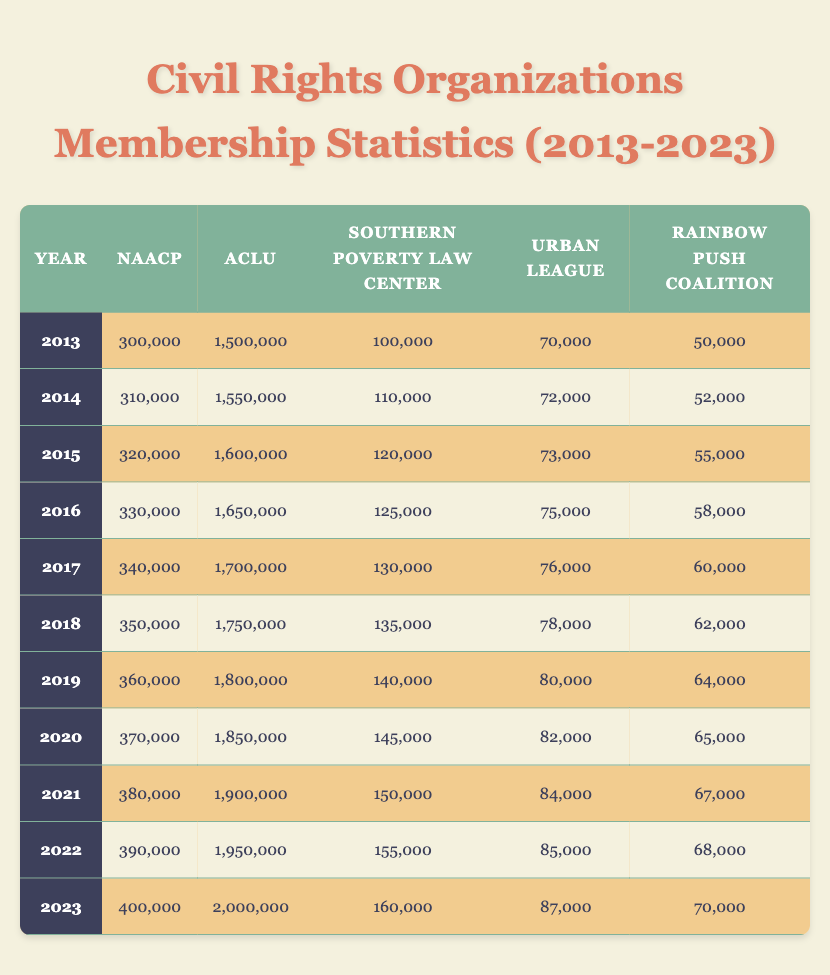What was the NAACP membership in 2013? The table shows that the NAACP membership in the year 2013 was listed as 300,000.
Answer: 300,000 Which organization had the highest membership in 2023? In 2023, the ACLU membership, which is 2,000,000, is higher than the memberships of other organizations listed for that year.
Answer: ACLU What is the difference in membership for the Southern Poverty Law Center between 2015 and 2020? For 2015, the Southern Poverty Law Center had a membership of 120,000 and in 2020 it was 145,000. The difference is 145,000 - 120,000 = 25,000.
Answer: 25,000 In which year did the Rainbow Push Coalition reach a membership of 60,000? By reviewing the table, it indicates that the Rainbow Push Coalition's membership reached 60,000 in 2017.
Answer: 2017 What was the average membership of the Urban League over the decade? To find the average, sum the Urban League memberships from 2013 to 2023, which are 70,000, 72,000, 73,000, 75,000, 76,000, 78,000, 80,000, 82,000, 84,000, 85,000, and 87,000, totaling  70,000 + 72,000 + 73,000 + 75,000 + 76,000 + 78,000 + 80,000 + 82,000 + 84,000 + 85,000 + 87,000 =  65,727. Dividing by 11 gives an average of approximately 81,000.
Answer: 81,000 Did the NAACP membership increase every year from 2013 to 2023? By examining the table, it's clear that the NAACP membership increased each year, starting from 300,000 in 2013 to 400,000 in 2023 without any decreases.
Answer: Yes What was the total membership for the ACLU over the years from 2013 to 2023? The total membership is found by adding the yearly memberships: 1,500,000 + 1,550,000 + 1,600,000 + 1,650,000 + 1,700,000 + 1,750,000 + 1,800,000 + 1,850,000 + 1,900,000 + 1,950,000 + 2,000,000 = 19,800,000.
Answer: 19,800,000 Which organization saw the smallest growth over the decade? By looking at the growth of each organization, the Rainbow Push Coalition’s membership increased from 50,000 in 2013 to 70,000 in 2023, showing a growth of 20,000. Other organizations had larger increments.
Answer: Rainbow Push Coalition What percentage growth did the Southern Poverty Law Center experience from 2013 to 2023? The membership in 2013 was 100,000 and in 2023 it was 160,000. The growth is 160,000 - 100,000 = 60,000. To find the percentage growth: (60,000 / 100,000) * 100 = 60%.
Answer: 60% Did the Urban League ever reach 90,000 members in this decade? The table shows that the Urban League's highest reported membership was 87,000 in 2023, which is below 90,000.
Answer: No 